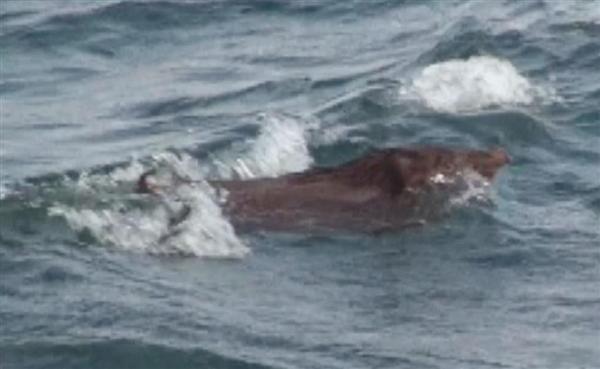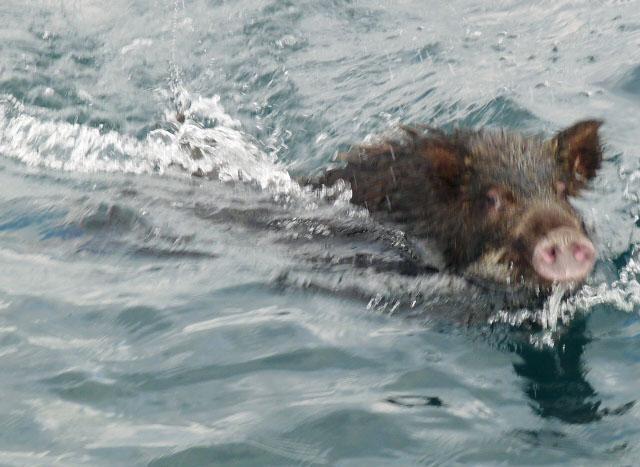The first image is the image on the left, the second image is the image on the right. For the images shown, is this caption "Left image shows one wild hog that is lying in shallow water at the shoreline." true? Answer yes or no. No. The first image is the image on the left, the second image is the image on the right. For the images shown, is this caption "At least one pig is swimming through the water." true? Answer yes or no. Yes. 